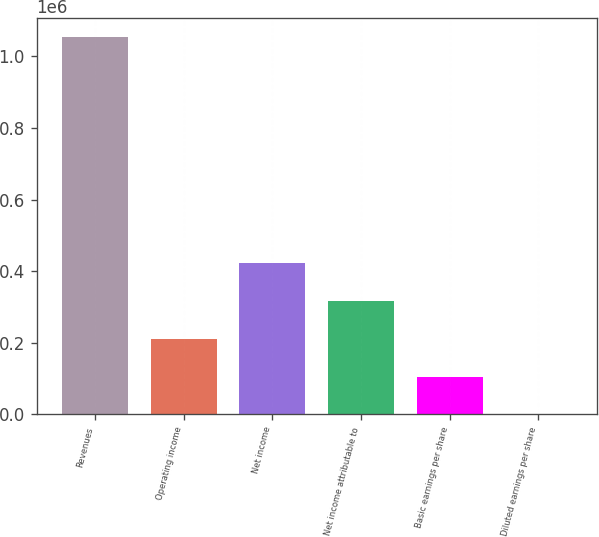Convert chart. <chart><loc_0><loc_0><loc_500><loc_500><bar_chart><fcel>Revenues<fcel>Operating income<fcel>Net income<fcel>Net income attributable to<fcel>Basic earnings per share<fcel>Diluted earnings per share<nl><fcel>1.05425e+06<fcel>210852<fcel>421702<fcel>316277<fcel>105427<fcel>1.51<nl></chart> 